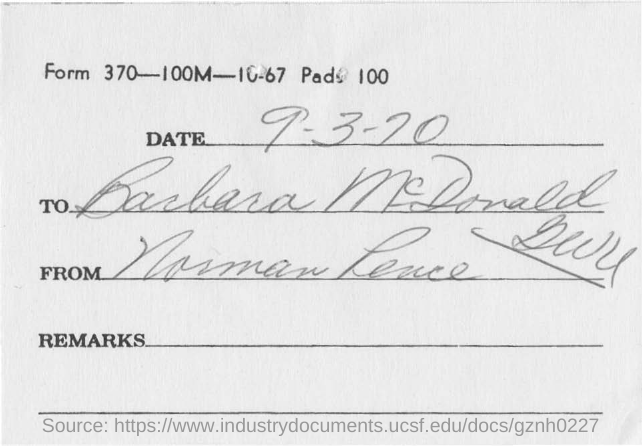What is the date mentioned in this document?
Offer a terse response. 9-3-20. To whom, the document is addressed?
Your answer should be very brief. Barbara McDonald. 